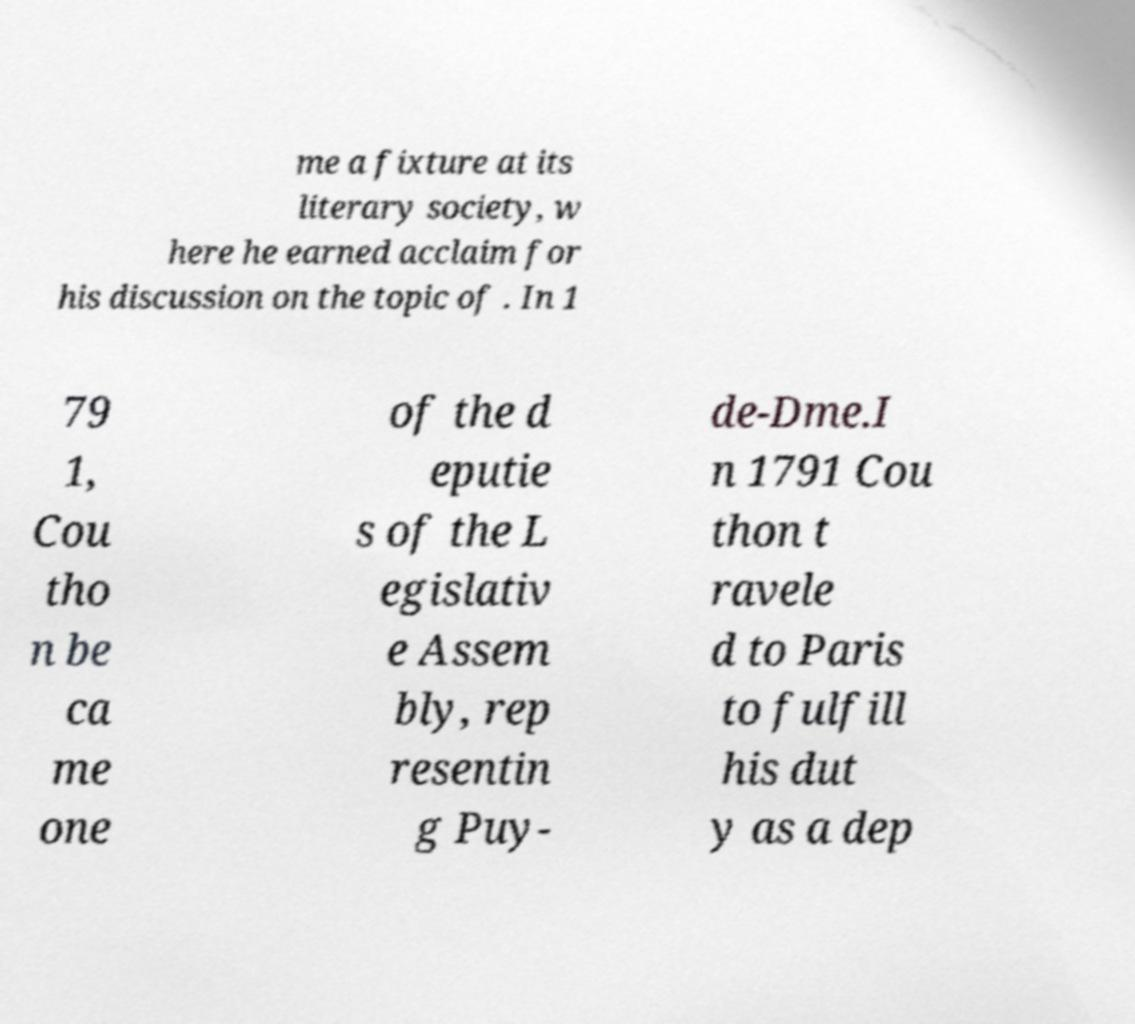Could you assist in decoding the text presented in this image and type it out clearly? me a fixture at its literary society, w here he earned acclaim for his discussion on the topic of . In 1 79 1, Cou tho n be ca me one of the d eputie s of the L egislativ e Assem bly, rep resentin g Puy- de-Dme.I n 1791 Cou thon t ravele d to Paris to fulfill his dut y as a dep 